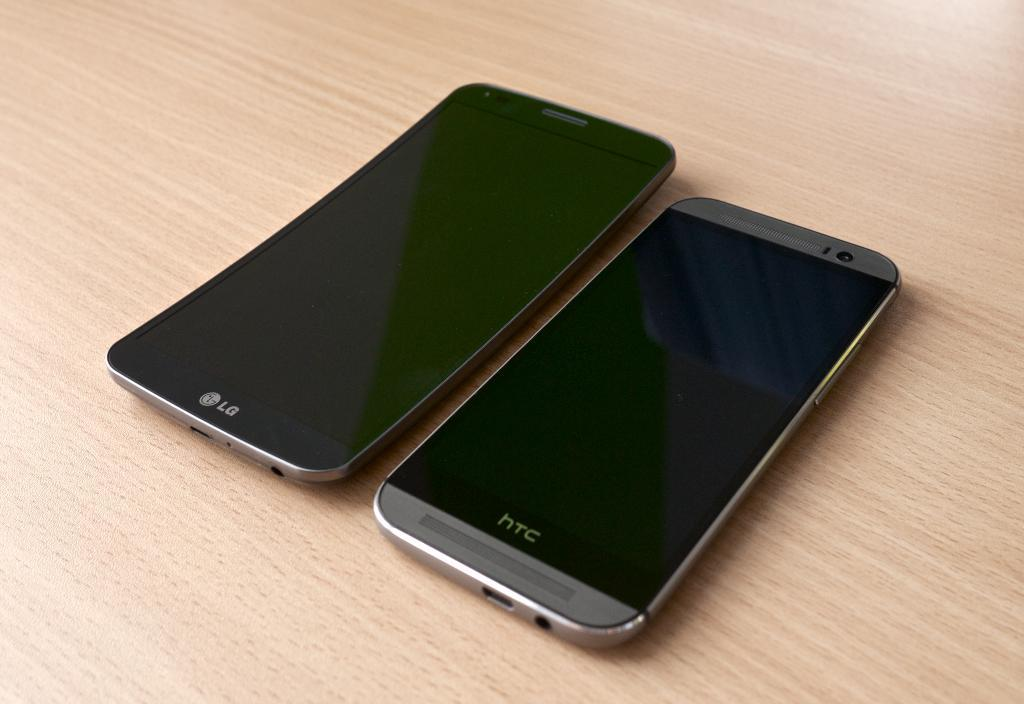<image>
Present a compact description of the photo's key features. Two cellphones, one HTC and one LG, sit on a wood grain table. 